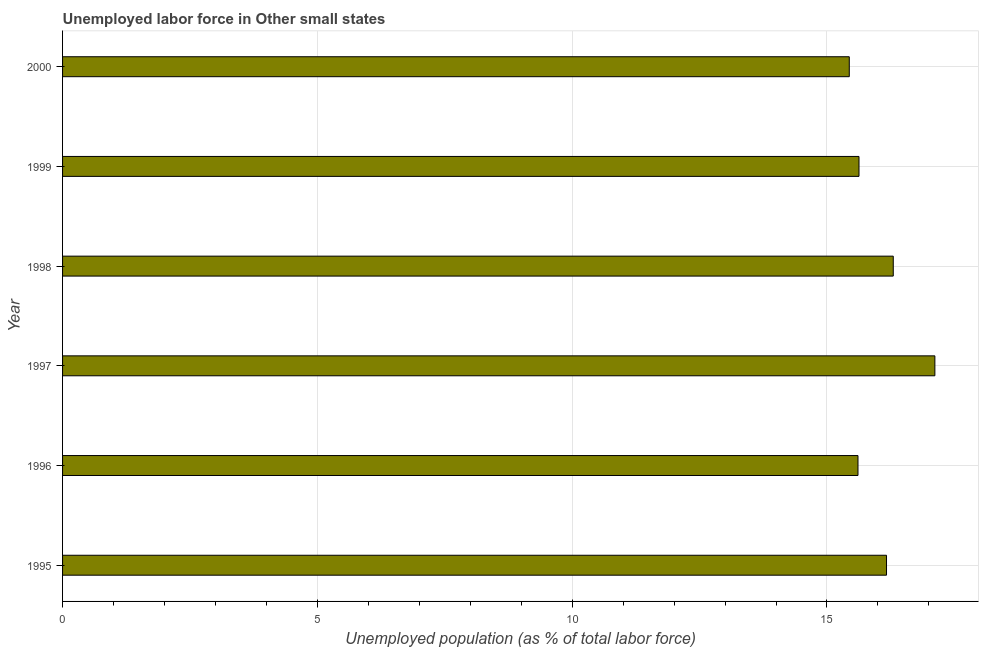What is the title of the graph?
Give a very brief answer. Unemployed labor force in Other small states. What is the label or title of the X-axis?
Give a very brief answer. Unemployed population (as % of total labor force). What is the label or title of the Y-axis?
Ensure brevity in your answer.  Year. What is the total unemployed population in 1999?
Give a very brief answer. 15.63. Across all years, what is the maximum total unemployed population?
Keep it short and to the point. 17.12. Across all years, what is the minimum total unemployed population?
Keep it short and to the point. 15.44. In which year was the total unemployed population minimum?
Your answer should be compact. 2000. What is the sum of the total unemployed population?
Your answer should be compact. 96.26. What is the difference between the total unemployed population in 1998 and 1999?
Your answer should be very brief. 0.67. What is the average total unemployed population per year?
Provide a short and direct response. 16.04. What is the median total unemployed population?
Make the answer very short. 15.9. What is the ratio of the total unemployed population in 1995 to that in 1999?
Provide a short and direct response. 1.03. Is the total unemployed population in 1996 less than that in 1998?
Your response must be concise. Yes. What is the difference between the highest and the second highest total unemployed population?
Your answer should be very brief. 0.82. What is the difference between the highest and the lowest total unemployed population?
Offer a very short reply. 1.68. How many bars are there?
Your answer should be compact. 6. What is the difference between two consecutive major ticks on the X-axis?
Make the answer very short. 5. Are the values on the major ticks of X-axis written in scientific E-notation?
Your response must be concise. No. What is the Unemployed population (as % of total labor force) of 1995?
Your response must be concise. 16.17. What is the Unemployed population (as % of total labor force) of 1996?
Offer a terse response. 15.61. What is the Unemployed population (as % of total labor force) in 1997?
Make the answer very short. 17.12. What is the Unemployed population (as % of total labor force) of 1998?
Provide a succinct answer. 16.3. What is the Unemployed population (as % of total labor force) in 1999?
Provide a short and direct response. 15.63. What is the Unemployed population (as % of total labor force) of 2000?
Ensure brevity in your answer.  15.44. What is the difference between the Unemployed population (as % of total labor force) in 1995 and 1996?
Provide a short and direct response. 0.56. What is the difference between the Unemployed population (as % of total labor force) in 1995 and 1997?
Offer a very short reply. -0.95. What is the difference between the Unemployed population (as % of total labor force) in 1995 and 1998?
Give a very brief answer. -0.13. What is the difference between the Unemployed population (as % of total labor force) in 1995 and 1999?
Provide a short and direct response. 0.54. What is the difference between the Unemployed population (as % of total labor force) in 1995 and 2000?
Your answer should be compact. 0.73. What is the difference between the Unemployed population (as % of total labor force) in 1996 and 1997?
Provide a succinct answer. -1.51. What is the difference between the Unemployed population (as % of total labor force) in 1996 and 1998?
Offer a very short reply. -0.69. What is the difference between the Unemployed population (as % of total labor force) in 1996 and 1999?
Provide a succinct answer. -0.02. What is the difference between the Unemployed population (as % of total labor force) in 1996 and 2000?
Keep it short and to the point. 0.17. What is the difference between the Unemployed population (as % of total labor force) in 1997 and 1998?
Provide a succinct answer. 0.82. What is the difference between the Unemployed population (as % of total labor force) in 1997 and 1999?
Your answer should be very brief. 1.49. What is the difference between the Unemployed population (as % of total labor force) in 1997 and 2000?
Your answer should be very brief. 1.68. What is the difference between the Unemployed population (as % of total labor force) in 1998 and 1999?
Offer a terse response. 0.67. What is the difference between the Unemployed population (as % of total labor force) in 1998 and 2000?
Provide a short and direct response. 0.86. What is the difference between the Unemployed population (as % of total labor force) in 1999 and 2000?
Ensure brevity in your answer.  0.19. What is the ratio of the Unemployed population (as % of total labor force) in 1995 to that in 1996?
Your response must be concise. 1.04. What is the ratio of the Unemployed population (as % of total labor force) in 1995 to that in 1997?
Provide a succinct answer. 0.94. What is the ratio of the Unemployed population (as % of total labor force) in 1995 to that in 1999?
Offer a very short reply. 1.03. What is the ratio of the Unemployed population (as % of total labor force) in 1995 to that in 2000?
Make the answer very short. 1.05. What is the ratio of the Unemployed population (as % of total labor force) in 1996 to that in 1997?
Ensure brevity in your answer.  0.91. What is the ratio of the Unemployed population (as % of total labor force) in 1996 to that in 1998?
Provide a succinct answer. 0.96. What is the ratio of the Unemployed population (as % of total labor force) in 1997 to that in 1998?
Give a very brief answer. 1.05. What is the ratio of the Unemployed population (as % of total labor force) in 1997 to that in 1999?
Ensure brevity in your answer.  1.09. What is the ratio of the Unemployed population (as % of total labor force) in 1997 to that in 2000?
Your answer should be compact. 1.11. What is the ratio of the Unemployed population (as % of total labor force) in 1998 to that in 1999?
Offer a very short reply. 1.04. What is the ratio of the Unemployed population (as % of total labor force) in 1998 to that in 2000?
Your answer should be compact. 1.06. 